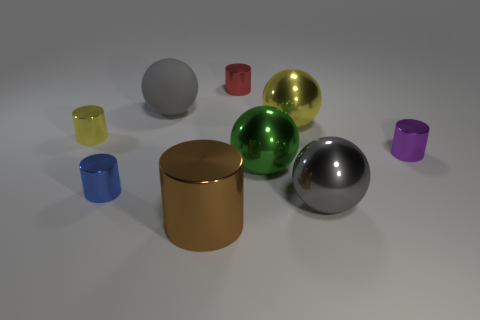Can you tell me which objects are the most reflective? The most reflective objects in the image are the gold cylinder and the silver sphere, as they have highly polished surfaces that reflect the light and the environment around them. 